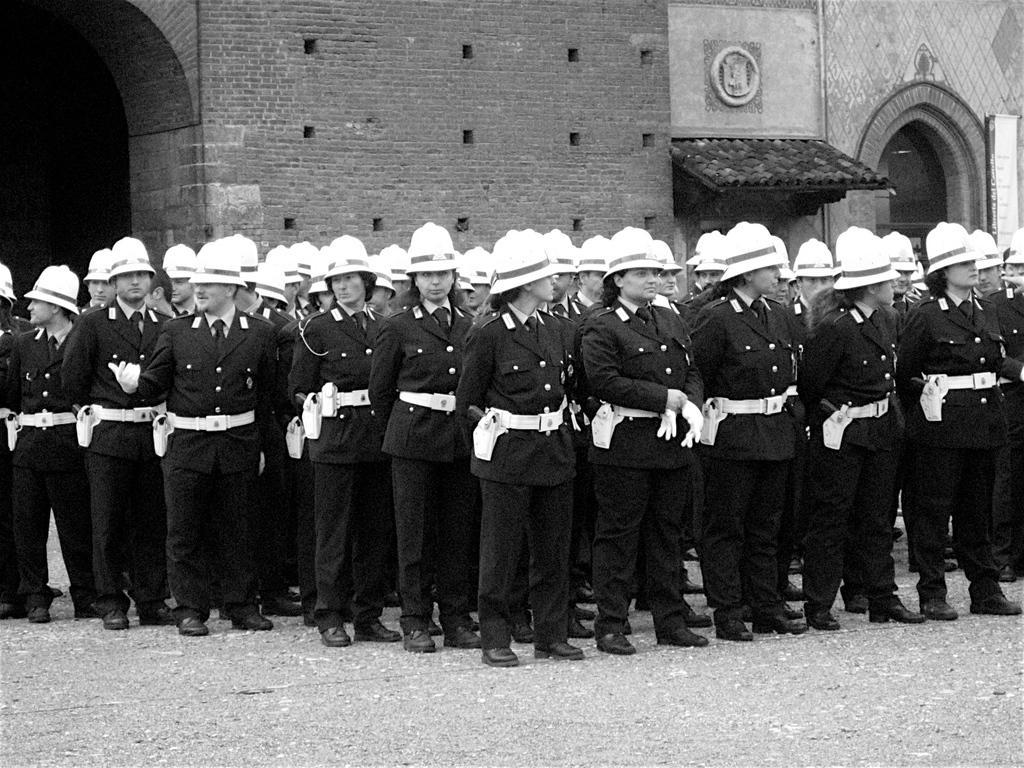What are the people in the image doing? The people in the image are standing on the ground. What protective gear are the people wearing? The people are wearing helmets. What can be seen in the background of the image? There is a building visible in the background of the image. What type of ice can be seen melting on the blade in the image? There is no ice or blade present in the image. 